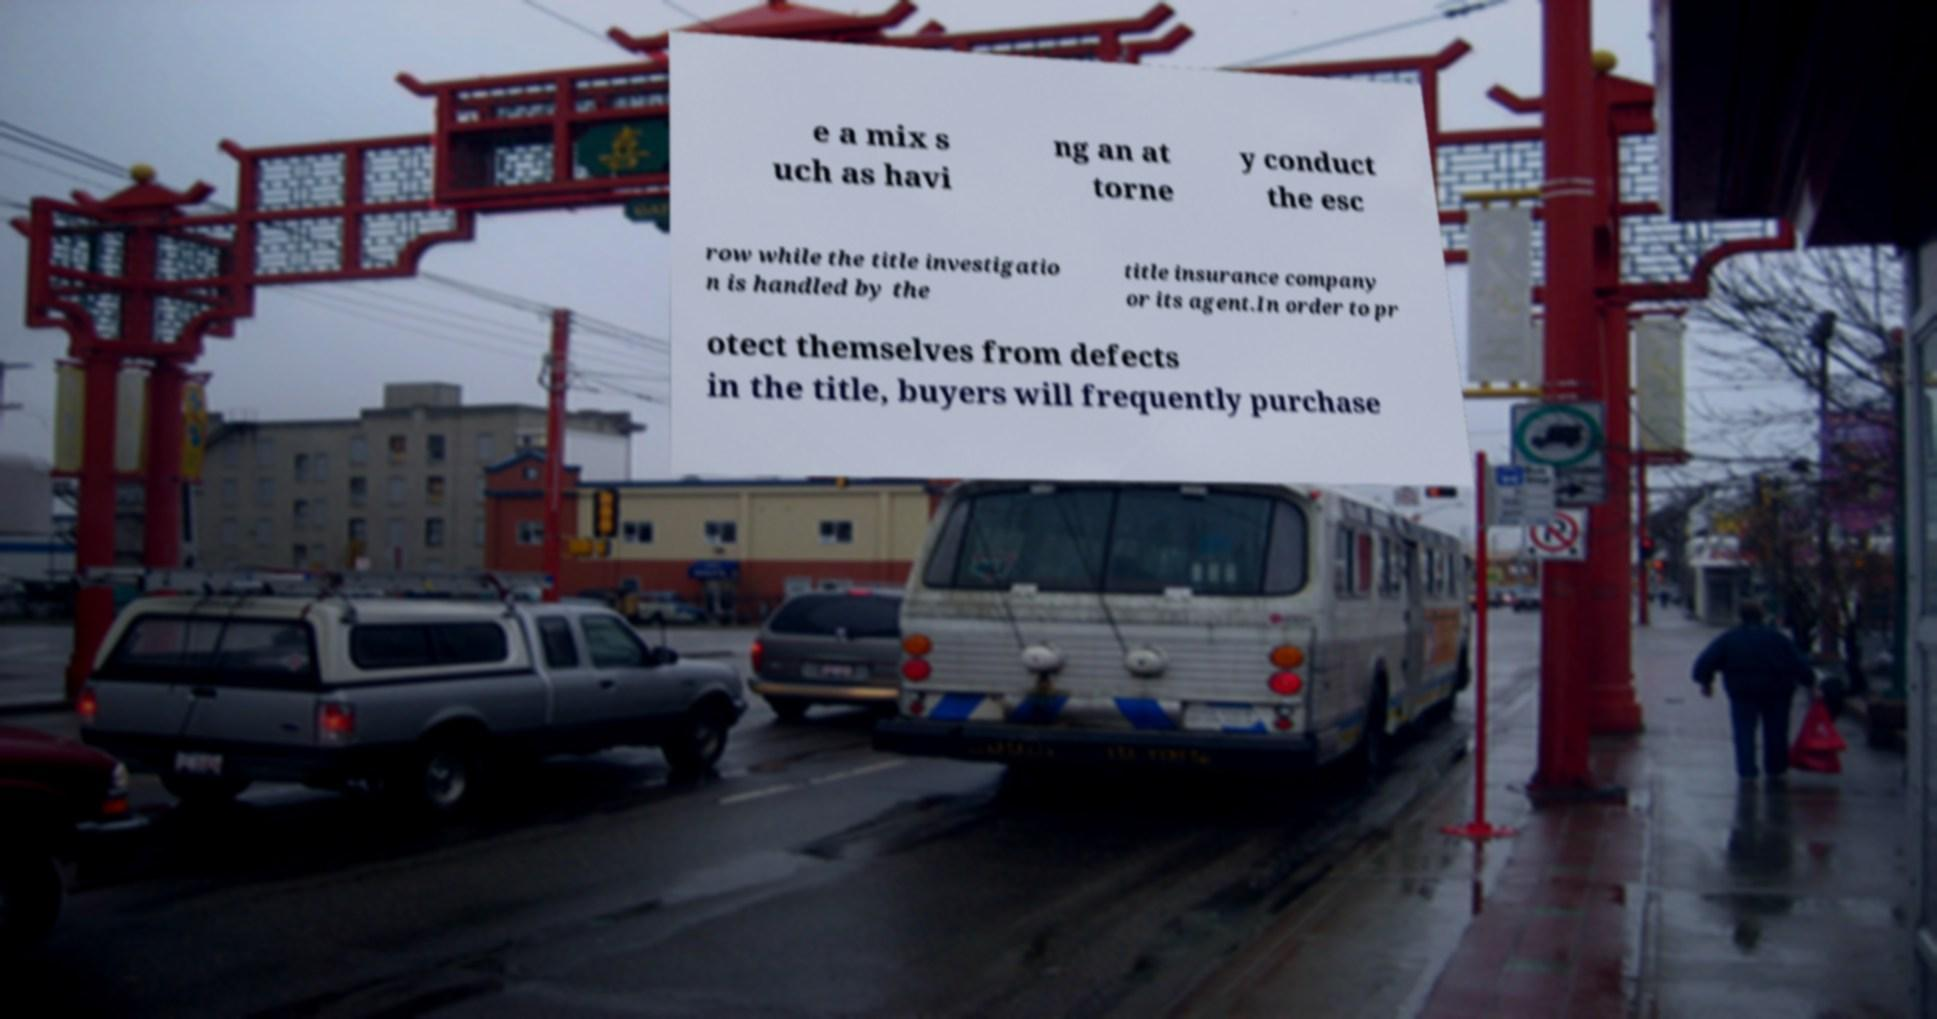Please identify and transcribe the text found in this image. e a mix s uch as havi ng an at torne y conduct the esc row while the title investigatio n is handled by the title insurance company or its agent.In order to pr otect themselves from defects in the title, buyers will frequently purchase 